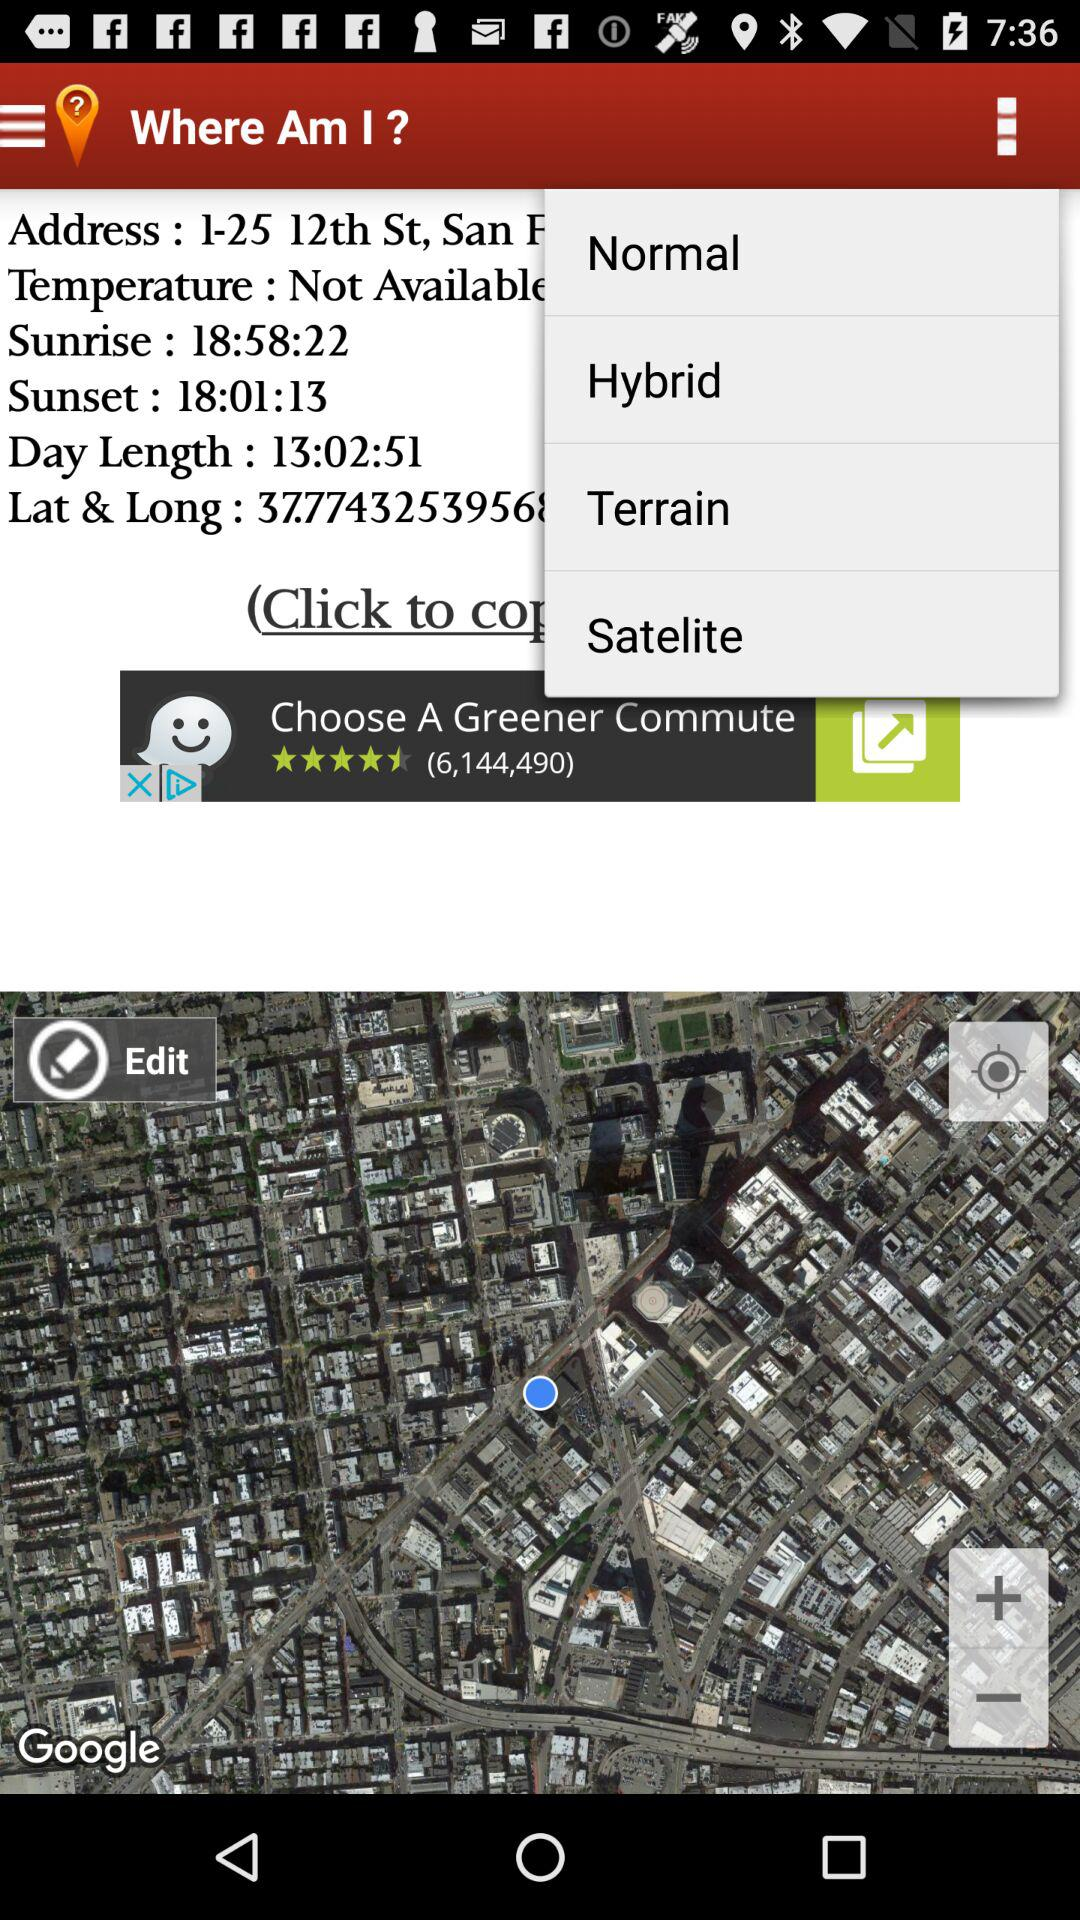What is the time of sunrise? The time of sunrise is 18:58:22. 